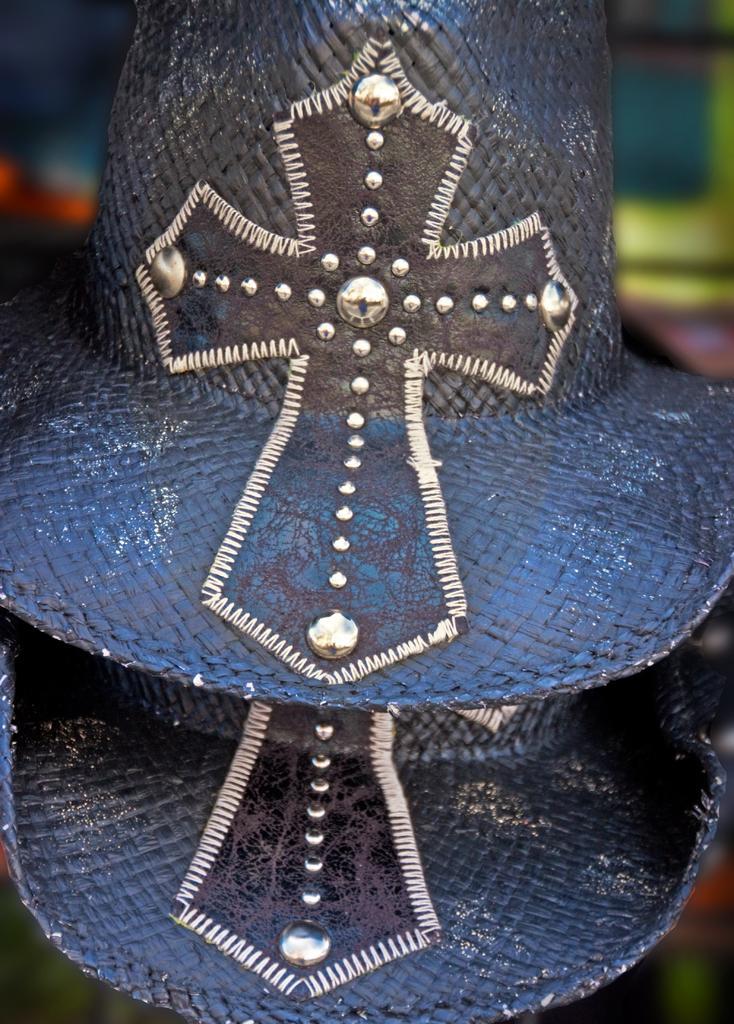Could you give a brief overview of what you see in this image? In this image we can see two hats and a blurry background. 